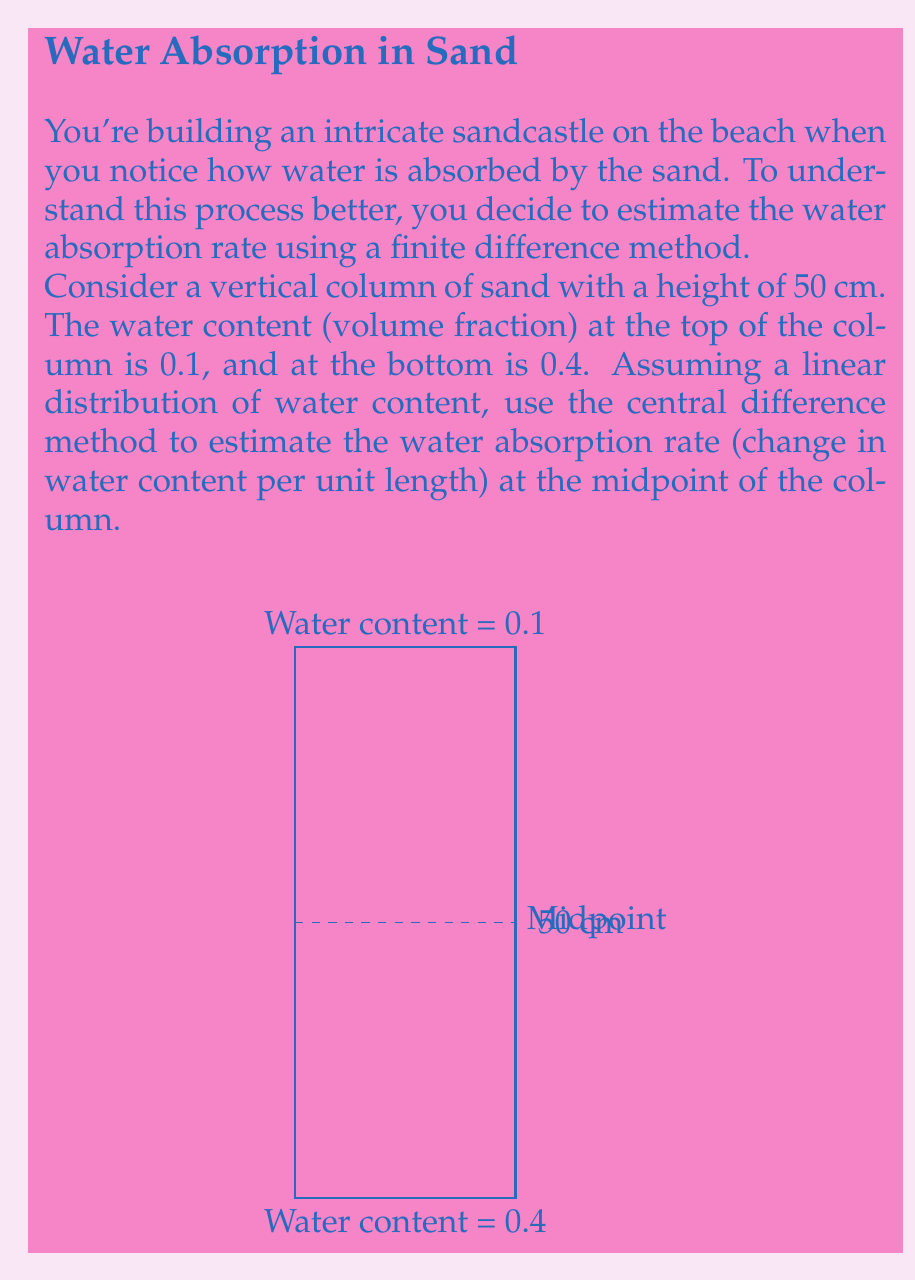What is the answer to this math problem? Let's approach this step-by-step:

1) The central difference method approximates the derivative (rate of change) at a point using values on either side of that point. The formula is:

   $$f'(x) \approx \frac{f(x+h) - f(x-h)}{2h}$$

   where $h$ is the step size.

2) In our case:
   - The function $f(x)$ represents the water content at height $x$.
   - We want to find the rate of change at the midpoint (25 cm).
   - The total height is 50 cm, so $h = 25$ cm.

3) We need to find $f(x+h)$ and $f(x-h)$:
   - $f(x+h)$ is the water content at the top: 0.1
   - $f(x-h)$ is the water content at the bottom: 0.4

4) Plugging into the central difference formula:

   $$f'(25) \approx \frac{f(50) - f(0)}{2(25)} = \frac{0.1 - 0.4}{50} = -\frac{0.3}{50} = -0.006$$

5) The negative sign indicates that the water content decreases as we move up the column.

6) To express this as a rate per cm, we keep the result as is: -0.006 per cm.
Answer: -0.006 per cm 